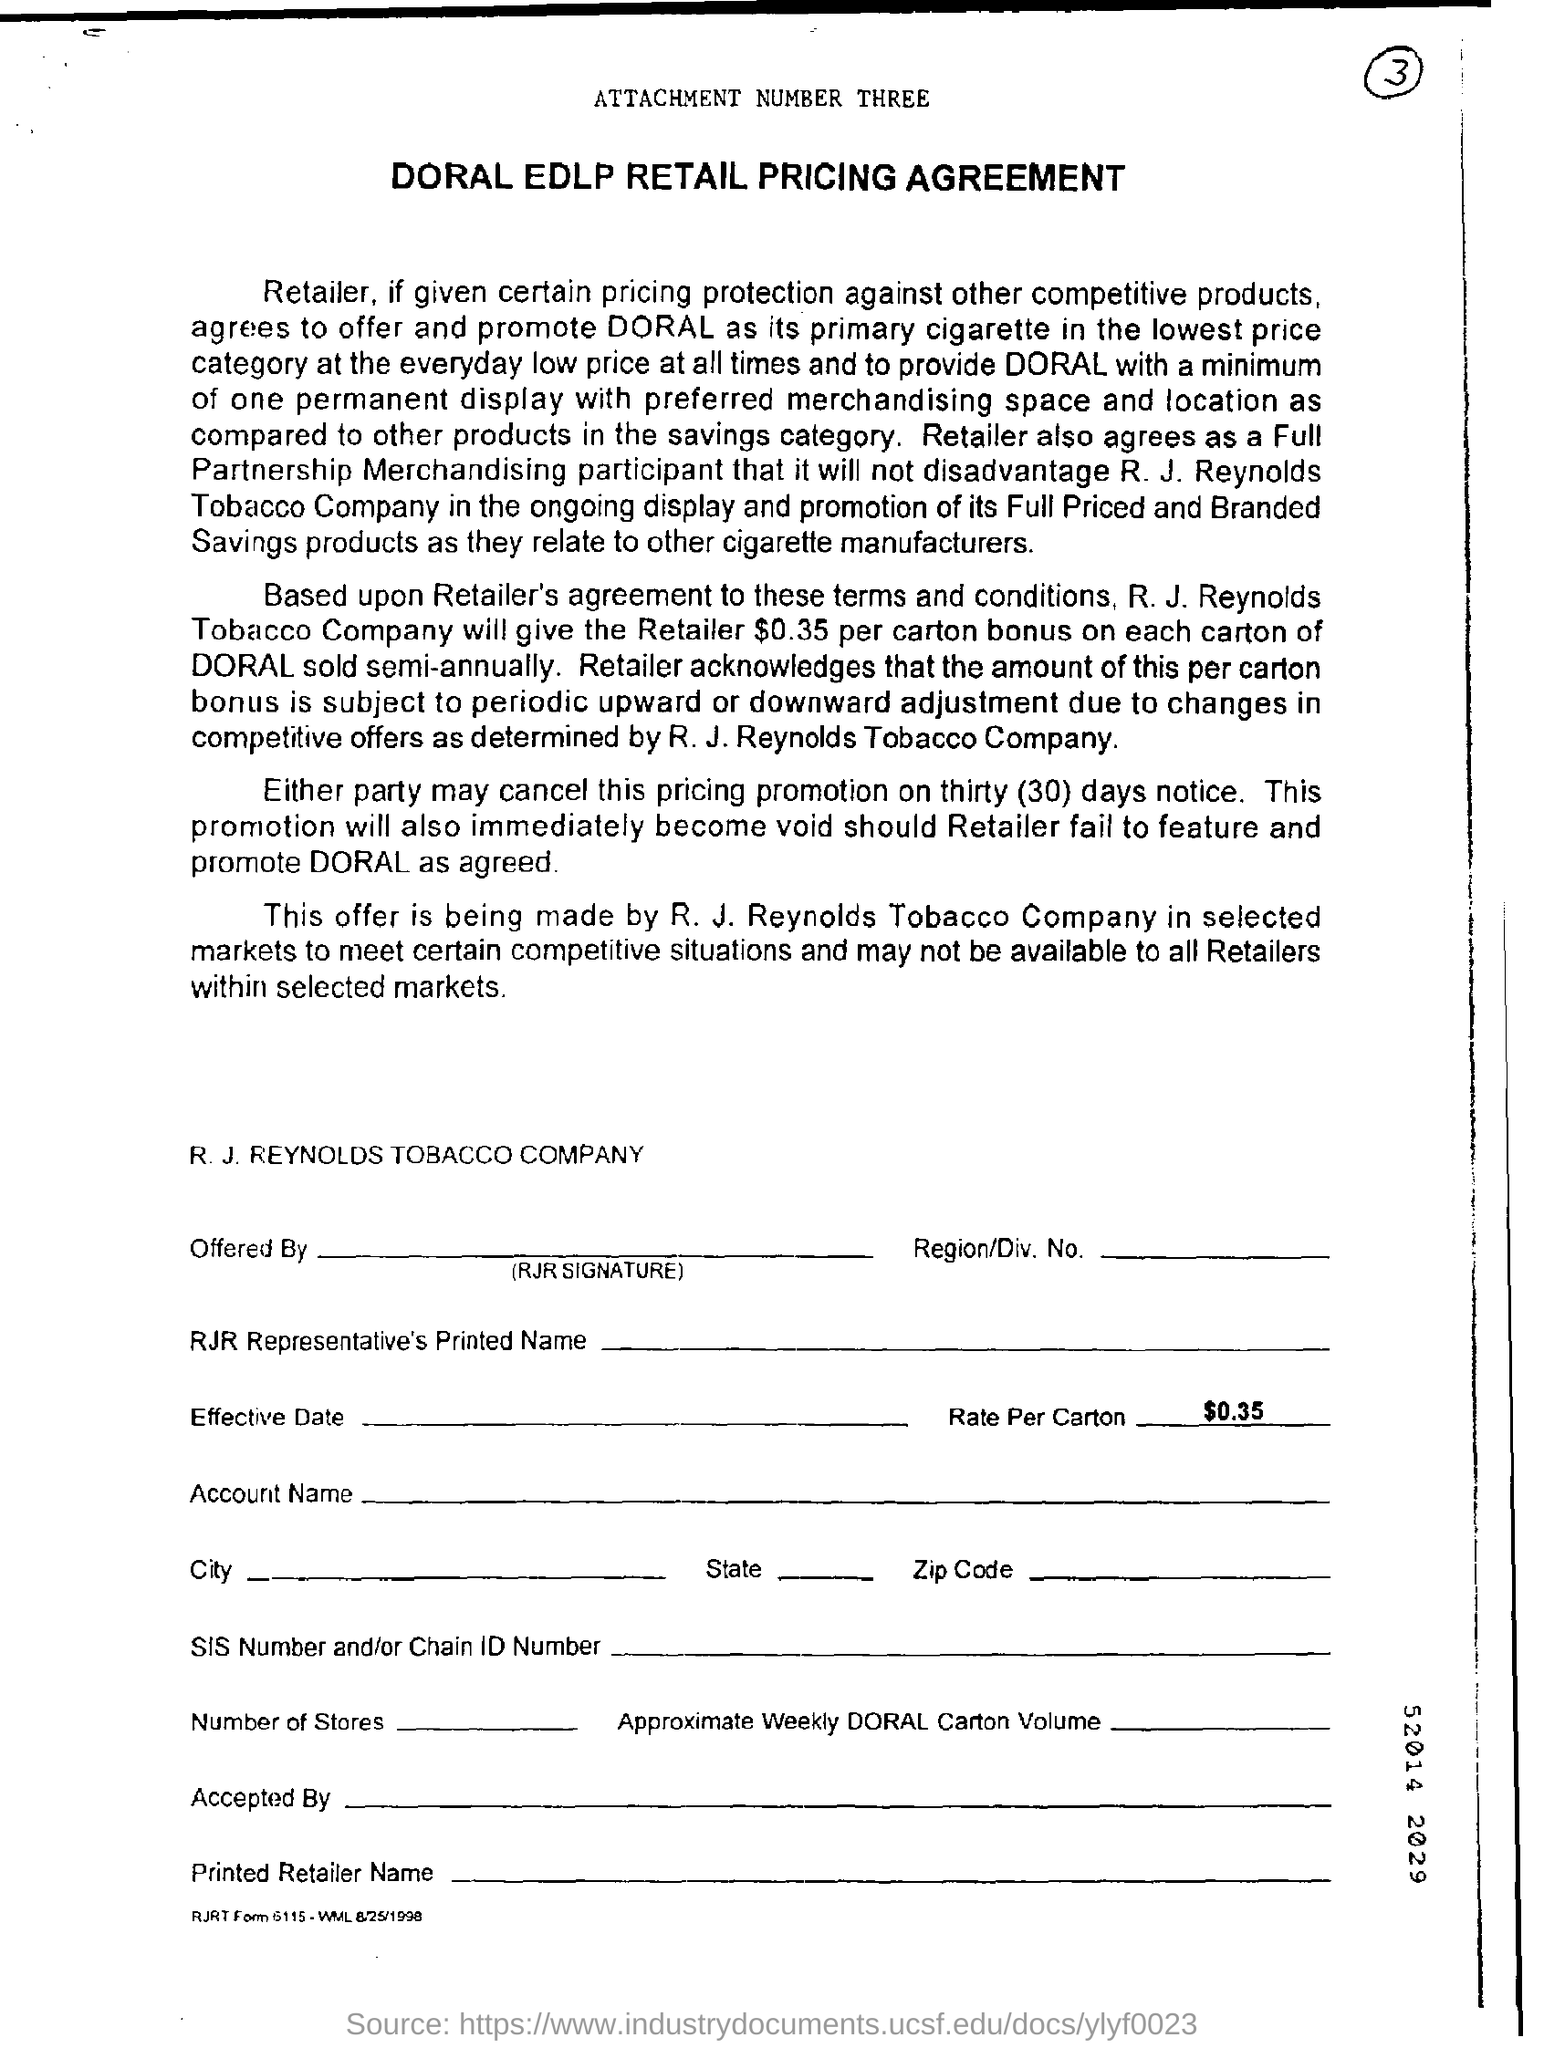List a handful of essential elements in this visual. The name of the company is R. J. REYNOLDS TOBACCO COMPANY. The document before me is a Declaration of the DORAL EDLP RETAIL PRICING AGREEMENT. 